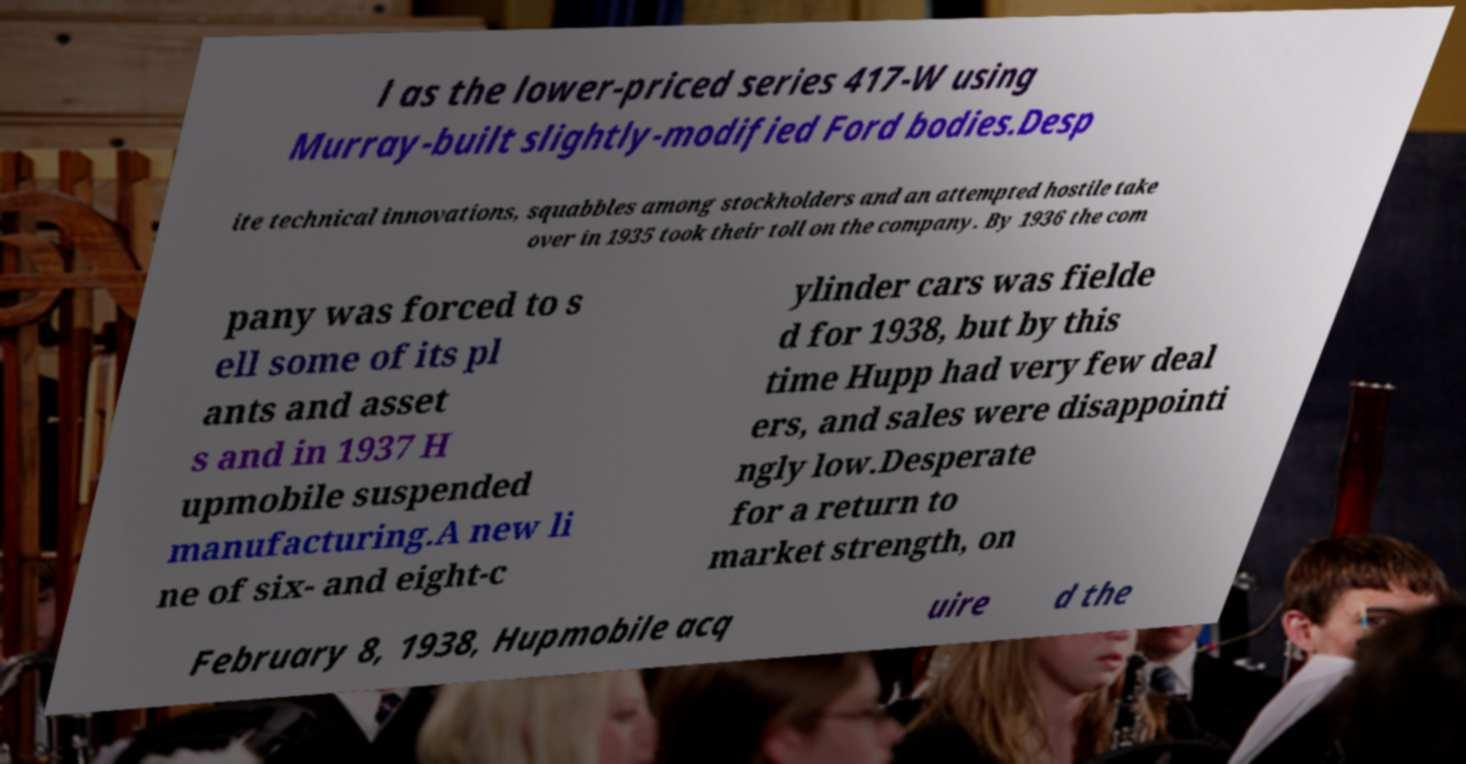Could you assist in decoding the text presented in this image and type it out clearly? l as the lower-priced series 417-W using Murray-built slightly-modified Ford bodies.Desp ite technical innovations, squabbles among stockholders and an attempted hostile take over in 1935 took their toll on the company. By 1936 the com pany was forced to s ell some of its pl ants and asset s and in 1937 H upmobile suspended manufacturing.A new li ne of six- and eight-c ylinder cars was fielde d for 1938, but by this time Hupp had very few deal ers, and sales were disappointi ngly low.Desperate for a return to market strength, on February 8, 1938, Hupmobile acq uire d the 